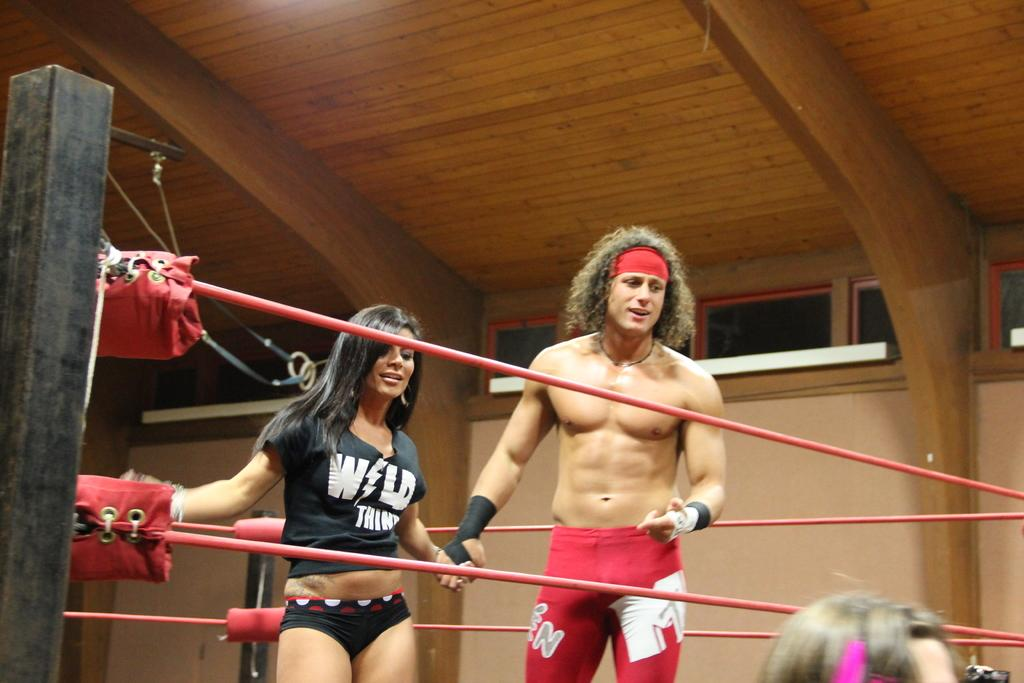How many people are in the image? There is a man and a woman in the image. What are the man and woman doing in the image? The man and woman are standing in a ring. What can be seen around the ring? There are threads around the ring. What type of ceiling is visible in the image? There is a wooden ceiling in the image. What color is the whip being used by the man in the image? There is no whip present in the image. How many chins does the woman have in the image? The number of chins cannot be determined from the image, as it is not a relevant detail. 